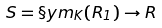Convert formula to latex. <formula><loc_0><loc_0><loc_500><loc_500>S = \S y m _ { K } ( R _ { 1 } ) \to R</formula> 